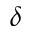Convert formula to latex. <formula><loc_0><loc_0><loc_500><loc_500>\delta</formula> 